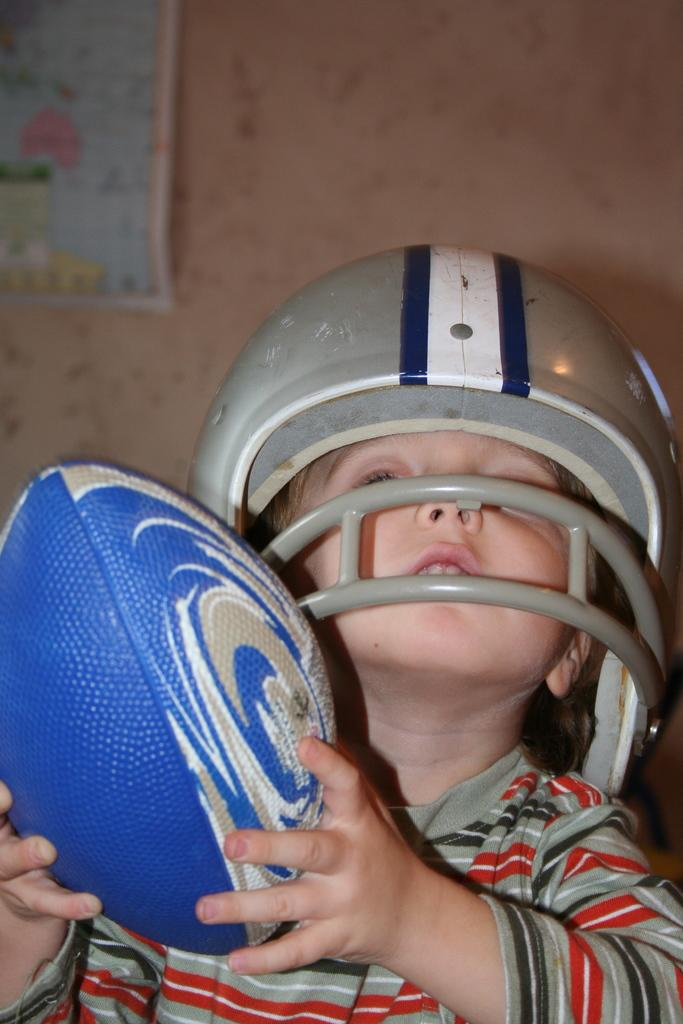What is the main subject of the image? The main subject of the image is a kid. What is the kid holding in the image? The kid is holding a rugby ball. What protective gear is the kid wearing? The kid is wearing a helmet. What can be seen in the background of the image? There is a wall in the background of the image. What is on the wall in the background? There is a map on the wall. Where is the cannon located in the image? There is no cannon present in the image. What type of faucet can be seen in the image? There is no faucet present in the image. 